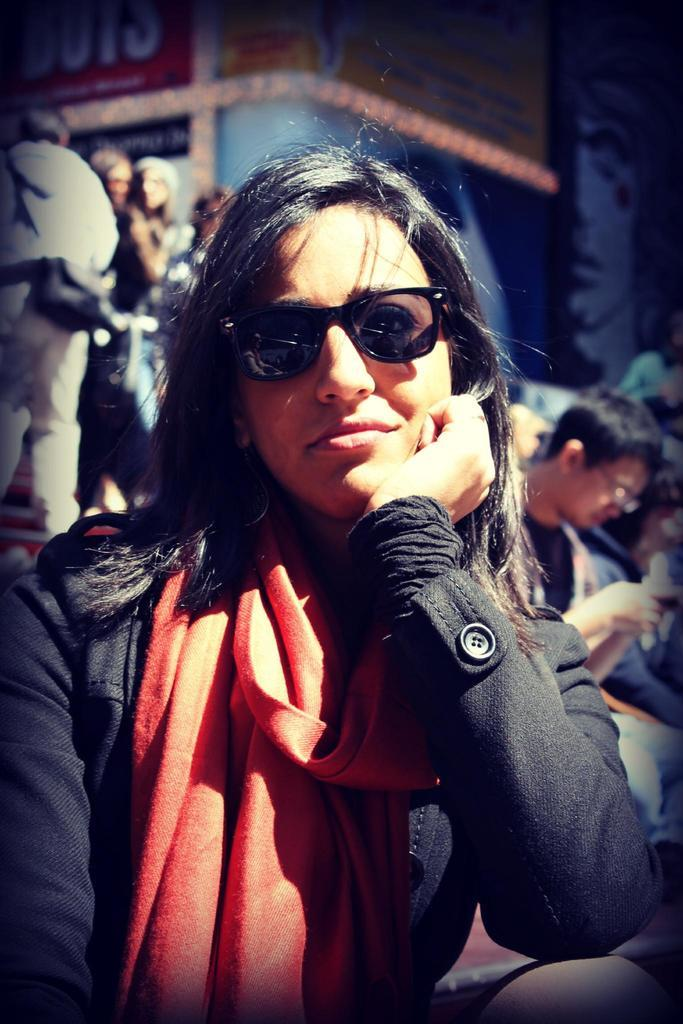Who is the main subject in the image? There is a woman in the image. What is the woman wearing? The woman is wearing spectacles. What is the woman's facial expression? The woman is smiling. What can be seen in the background of the image? There is a group of people, posters, and some objects in the background of the image. What type of thrill can be seen in the woman's eyes in the image? There is no indication of a thrill or any specific emotion in the woman's eyes in the image. 